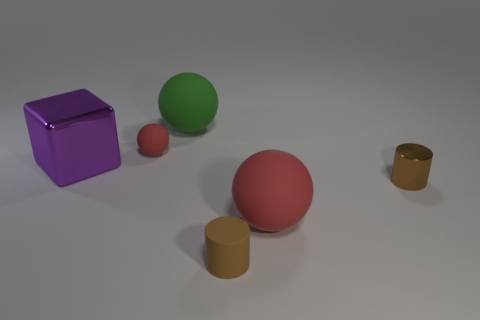How many other things are there of the same color as the small metal thing?
Make the answer very short. 1. Is the green sphere made of the same material as the large red ball?
Your answer should be compact. Yes. The small brown shiny thing has what shape?
Offer a terse response. Cylinder. How many red spheres are on the right side of the large matte object behind the tiny brown cylinder behind the tiny brown rubber thing?
Provide a succinct answer. 1. There is another large rubber thing that is the same shape as the green thing; what color is it?
Your response must be concise. Red. The small matte object in front of the brown cylinder behind the rubber ball on the right side of the large green rubber sphere is what shape?
Your answer should be very brief. Cylinder. What size is the rubber object that is both in front of the green rubber object and on the left side of the brown rubber object?
Your answer should be very brief. Small. Are there fewer tiny red cylinders than small red matte objects?
Make the answer very short. Yes. There is a rubber sphere in front of the purple cube; how big is it?
Give a very brief answer. Large. What shape is the matte thing that is both to the left of the large red sphere and in front of the brown metallic thing?
Provide a short and direct response. Cylinder. 